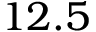<formula> <loc_0><loc_0><loc_500><loc_500>1 2 . 5</formula> 